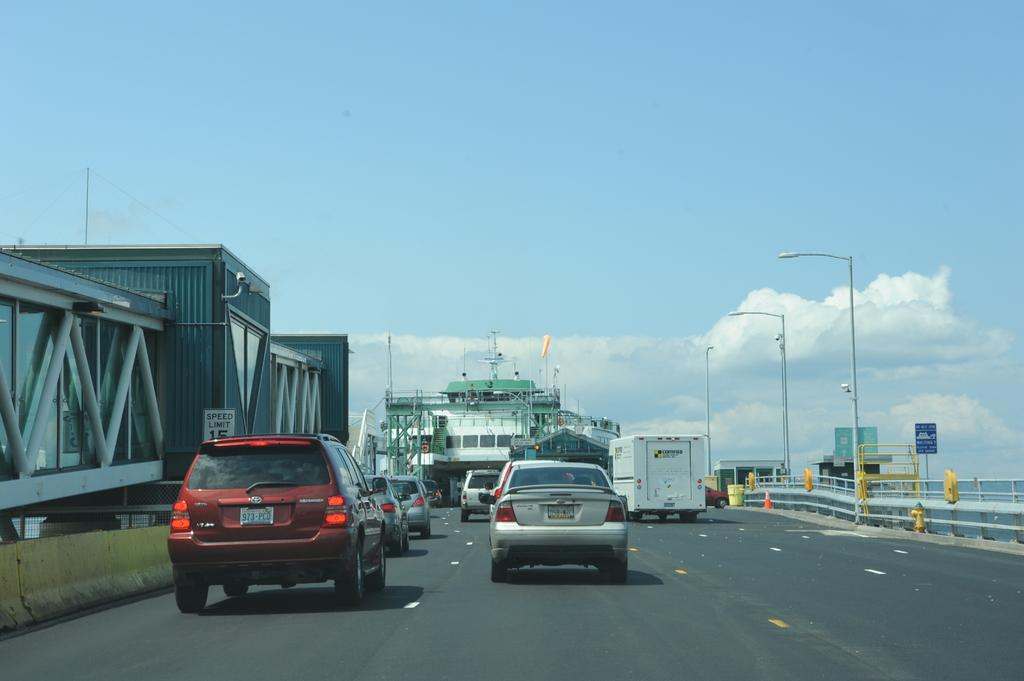What can be seen on the road in the image? There are vehicles on the road in the image. What type of barrier is present in the image? There is a fence in the image. What structures can be seen in the image? There are poles, a traffic cone, sheds, and boards present in the image. What is visible in the background of the image? The sky is visible in the background of the image, with clouds present. What type of breakfast is being served in the image? There is no breakfast present in the image. What is the plot of the story being told in the image? The image does not depict a story or plot; it is a scene with various objects and structures. 